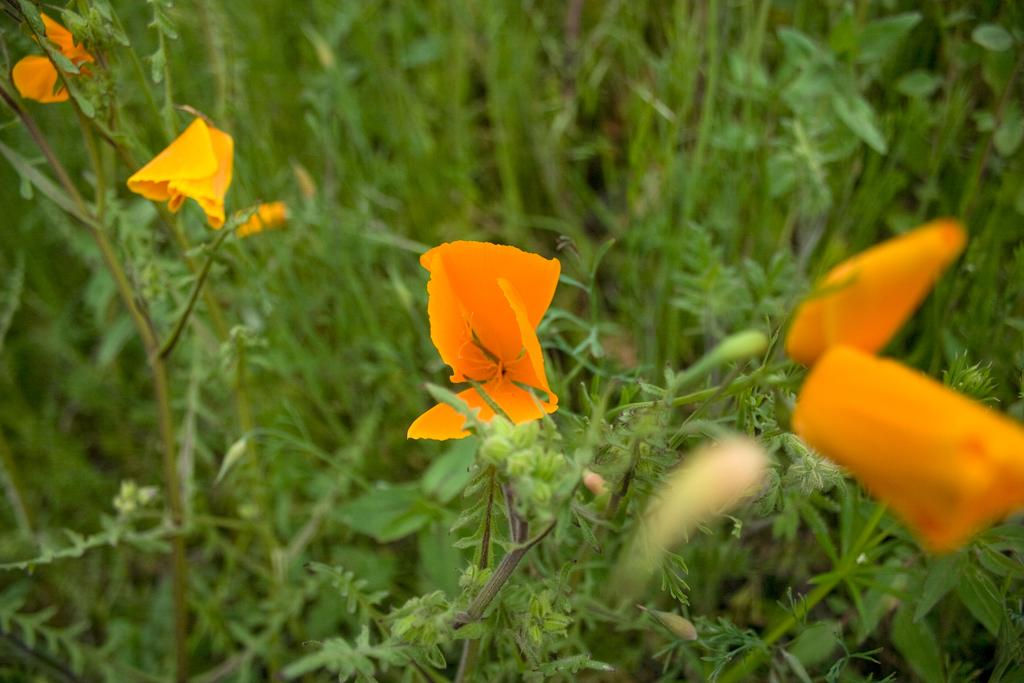What is the main subject of the image? The main subject of the image is a group of plants. What can be observed about the plants in the image? The plants have flowers. What type of comb can be seen in the image? There is no comb present in the image. Can you describe the feathers on the plants in the image? There are no feathers on the plants in the image; they have flowers instead. 